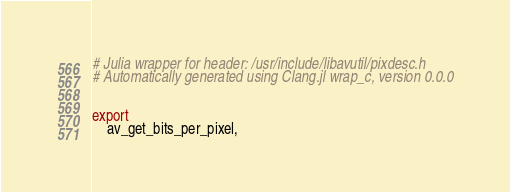<code> <loc_0><loc_0><loc_500><loc_500><_Julia_># Julia wrapper for header: /usr/include/libavutil/pixdesc.h
# Automatically generated using Clang.jl wrap_c, version 0.0.0


export
    av_get_bits_per_pixel,</code> 